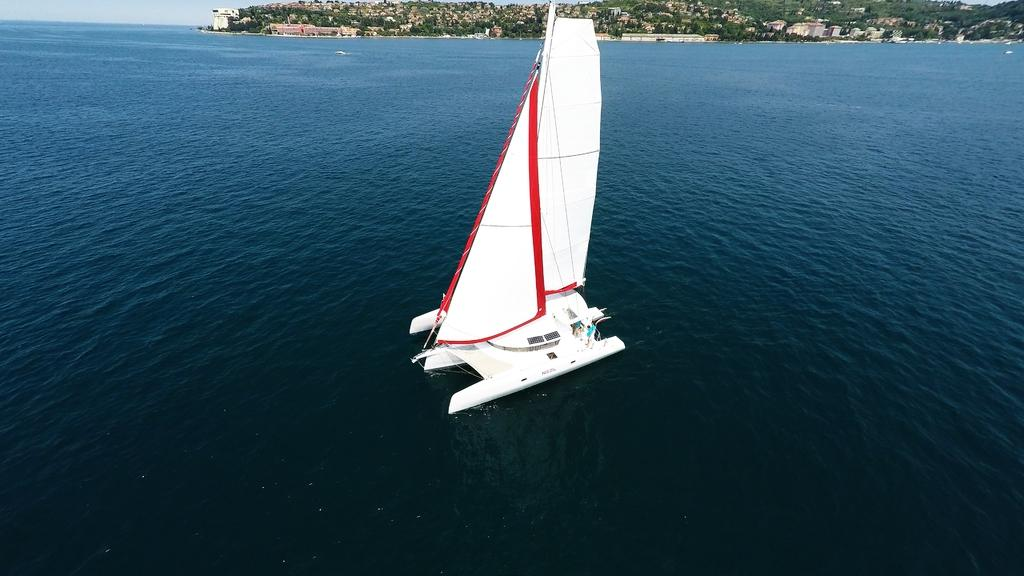What is the main subject of the image? The main subject of the image is a boat. Where is the boat located? The boat is on a river. What can be seen in the background of the image? There are buildings, trees, and the sky visible in the background of the image. What type of trail can be seen in the image? There is no trail present in the image; it features a boat on a river with buildings, trees, and the sky in the background. 